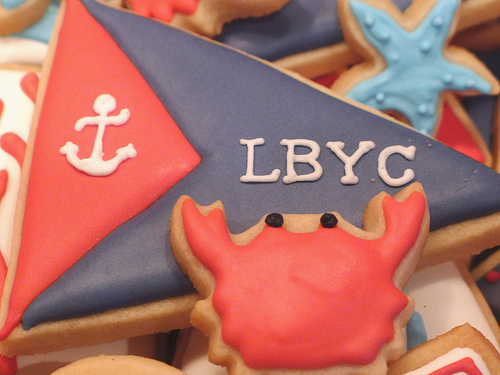<image>
Is there a crab cookie under the flag cookie? No. The crab cookie is not positioned under the flag cookie. The vertical relationship between these objects is different. 